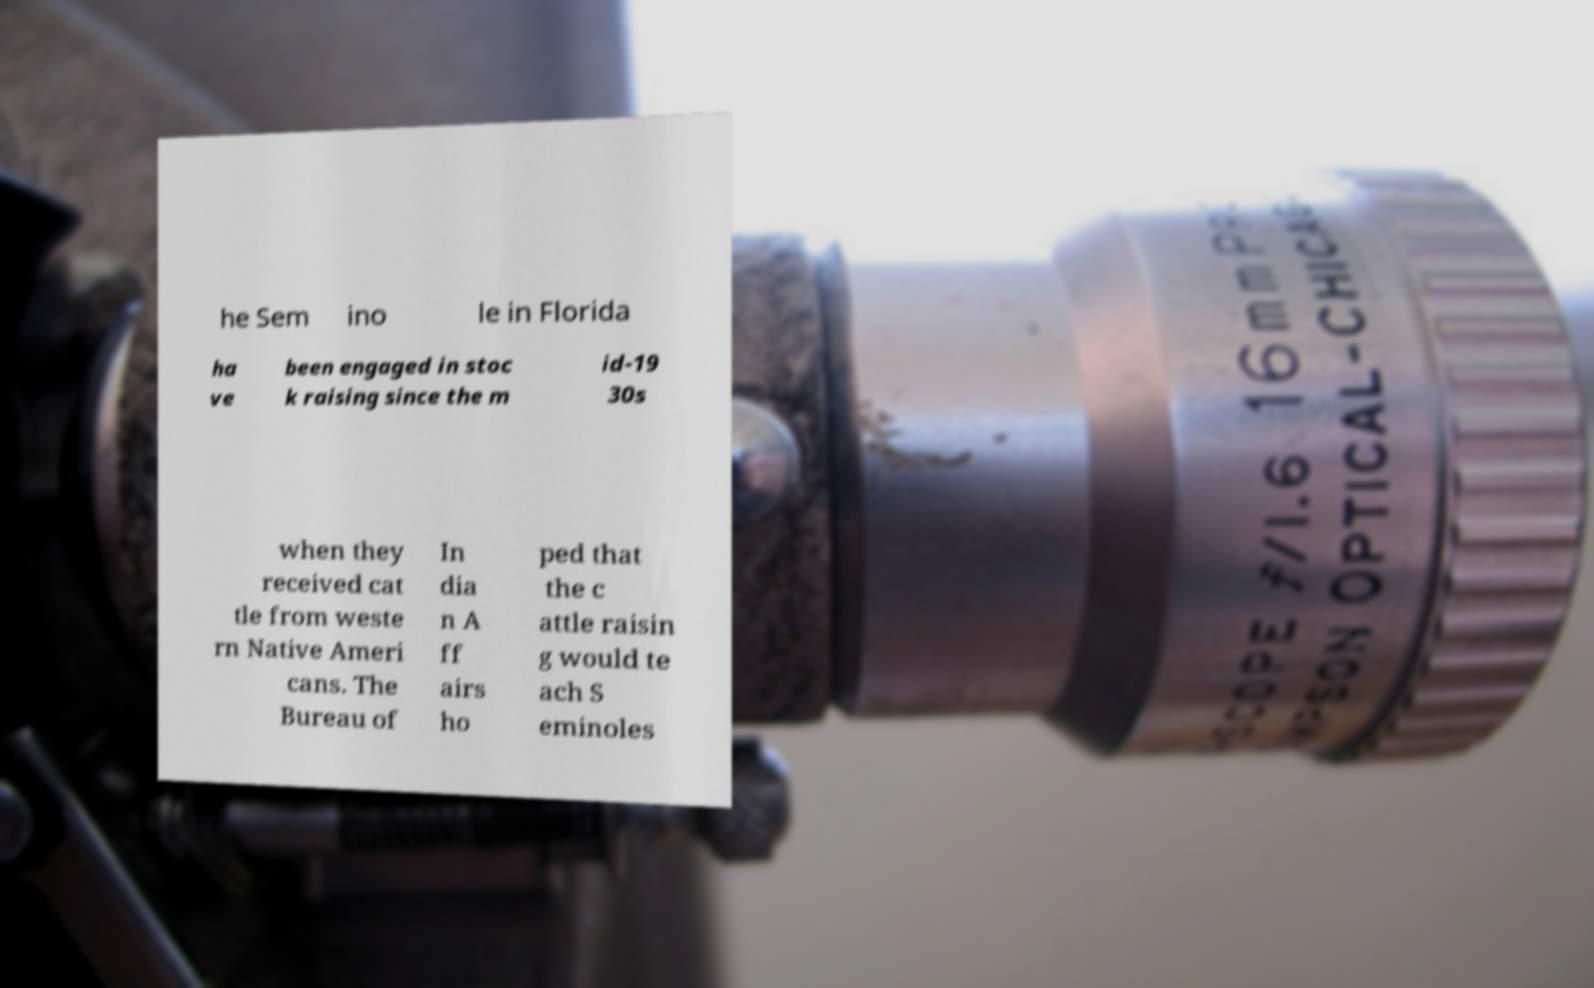What messages or text are displayed in this image? I need them in a readable, typed format. he Sem ino le in Florida ha ve been engaged in stoc k raising since the m id-19 30s when they received cat tle from weste rn Native Ameri cans. The Bureau of In dia n A ff airs ho ped that the c attle raisin g would te ach S eminoles 